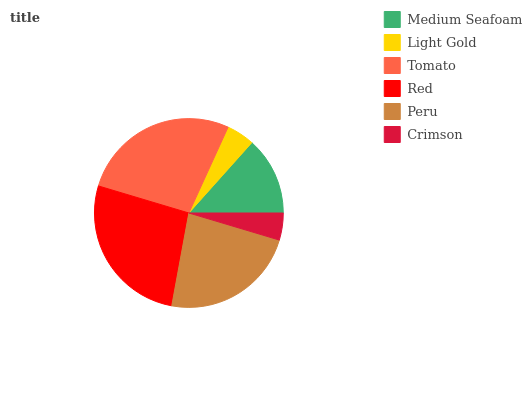Is Crimson the minimum?
Answer yes or no. Yes. Is Tomato the maximum?
Answer yes or no. Yes. Is Light Gold the minimum?
Answer yes or no. No. Is Light Gold the maximum?
Answer yes or no. No. Is Medium Seafoam greater than Light Gold?
Answer yes or no. Yes. Is Light Gold less than Medium Seafoam?
Answer yes or no. Yes. Is Light Gold greater than Medium Seafoam?
Answer yes or no. No. Is Medium Seafoam less than Light Gold?
Answer yes or no. No. Is Peru the high median?
Answer yes or no. Yes. Is Medium Seafoam the low median?
Answer yes or no. Yes. Is Light Gold the high median?
Answer yes or no. No. Is Peru the low median?
Answer yes or no. No. 